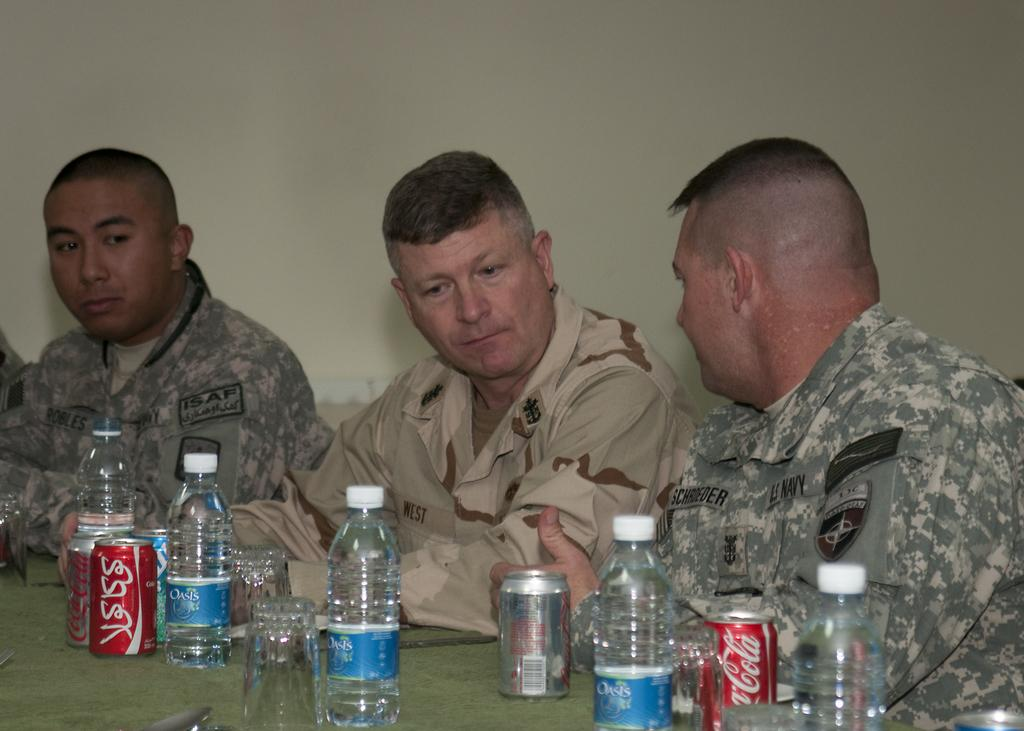How many men are in the image? There are three men in the image. What are the men doing in the image? The men are sitting. What objects are in front of the men? There are bottles, glasses, and cans in front of the men. What type of tramp can be seen performing in the image? There is no tramp performing in the image; it features three men sitting with bottles, glasses, and cans in front of them. How do the acoustics of the room affect the conversation in the image? There is no conversation taking place in the image, so it is not possible to determine how the acoustics of the room might affect it. 